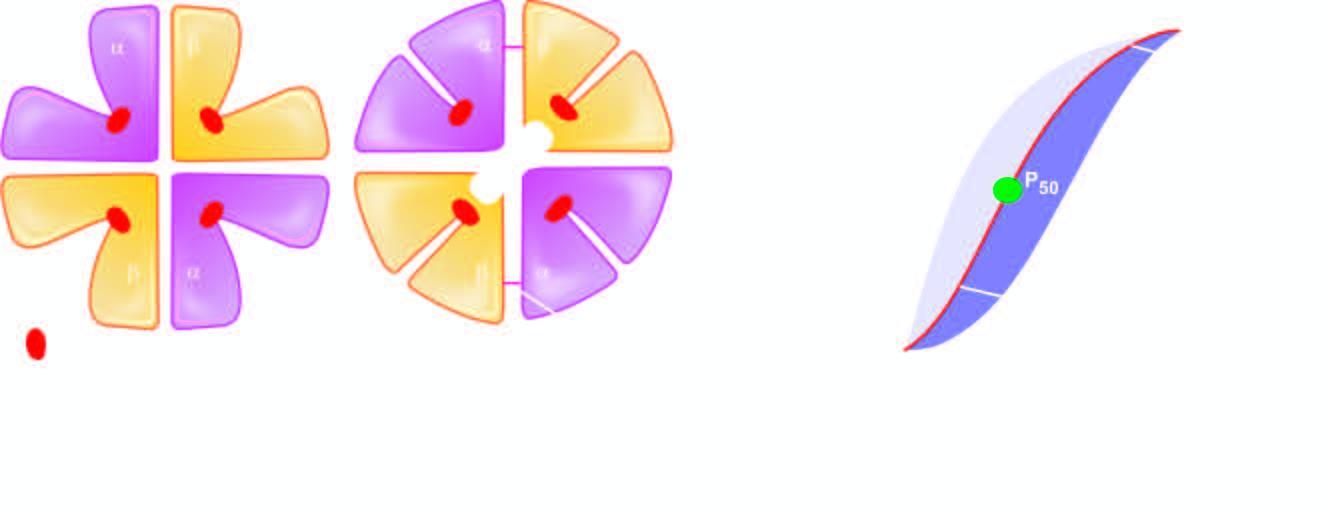re the centres of whorls of smooth muscle and connective tissue formed again?
Answer the question using a single word or phrase. No 